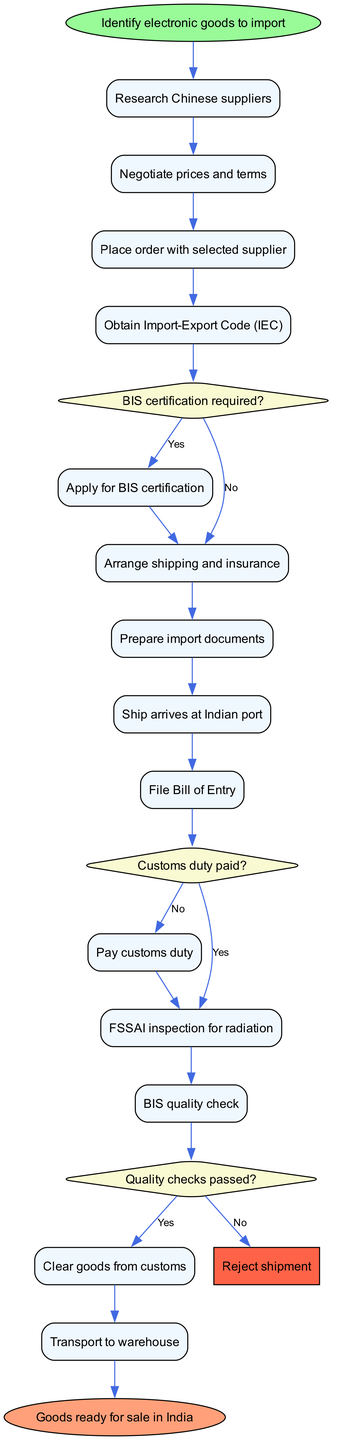What is the first activity in the diagram? The diagram starts with the 'Identify electronic goods to import' node, indicating it as the initial step in the process.
Answer: Identify electronic goods to import How many activities are there in total? Counting all the activities listed in the diagram, there are 14 activities.
Answer: 14 What is the decision made after obtaining the Import-Export Code? The decision made is whether BIS certification is required or not, which branches into two paths in the diagram.
Answer: BIS certification required? What happens if the customs duty is not paid? If the customs duty is not paid, the next required action in the flow is to 'Pay customs duty,' preventing further progress until it is completed.
Answer: Pay customs duty What will occur if the quality checks do not pass? If the quality checks do not pass, the flow leads to 'Reject shipment,' indicating that the goods will not be cleared for customs.
Answer: Reject shipment What is the final step in the process? The last step recorded in the diagram is 'Goods ready for sale in India,' showing the ultimate outcome of the entire import process.
Answer: Goods ready for sale in India What is the significance of the diamond-shaped nodes in the diagram? The diamond-shaped nodes represent decision points where a yes or no response determines the subsequent step, affecting the flow of activities.
Answer: Decision points How many decisions are represented in the diagram? There are three decision points depicted in the diagram, each asking a crucial question that influences the process flow.
Answer: 3 What does the node labeled 'Reject shipment' signify? The 'Reject shipment' node indicates that if the quality checks fail, the goods will be disallowed from entering the country, marking an end to that specific shipment process.
Answer: Reject shipment 